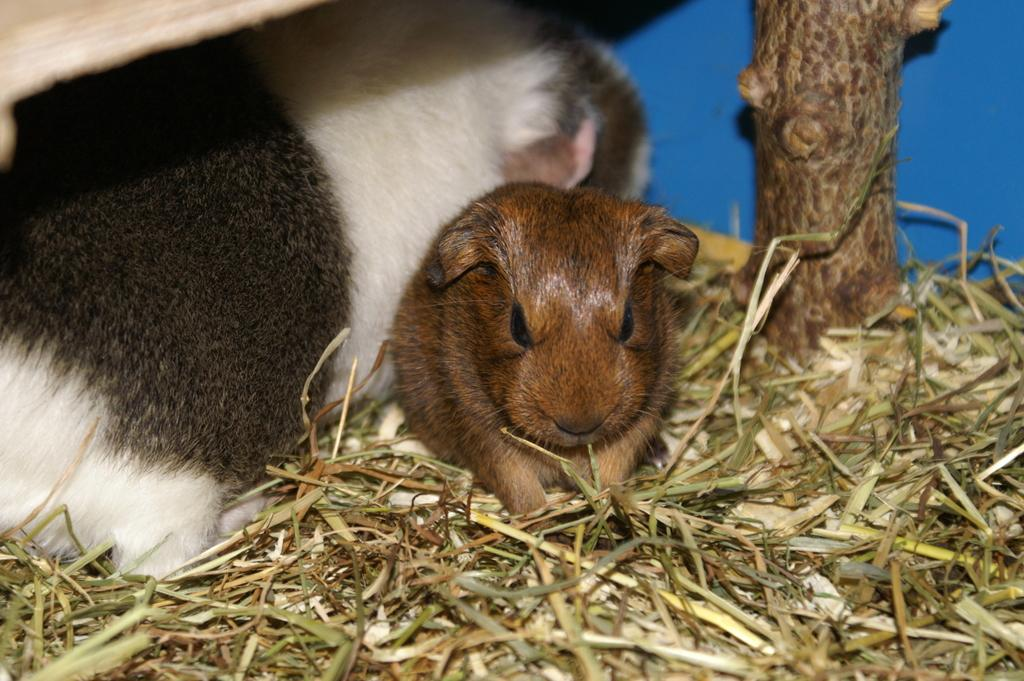How many animals are present in the image? There are two animals in the image. What is the surface on which the animals are standing? The animals are on dried grass. Can you describe the tree in the image? There is a tree in the image, and its bark is visible on the right side. What type of jewel can be seen hanging from the tree in the image? There is no jewel present in the image; only the animals, dried grass, and tree are visible. 